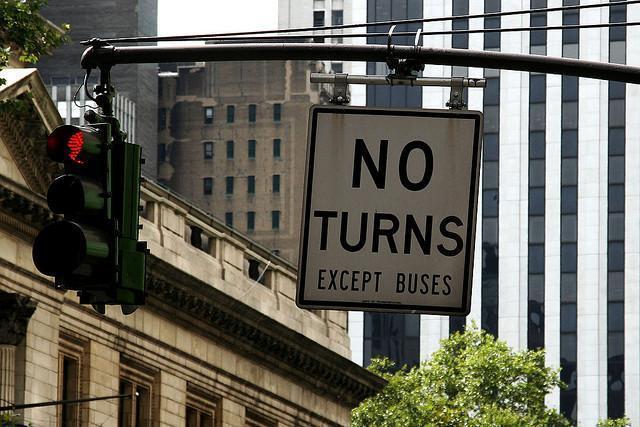How many people are standing?
Give a very brief answer. 0. 